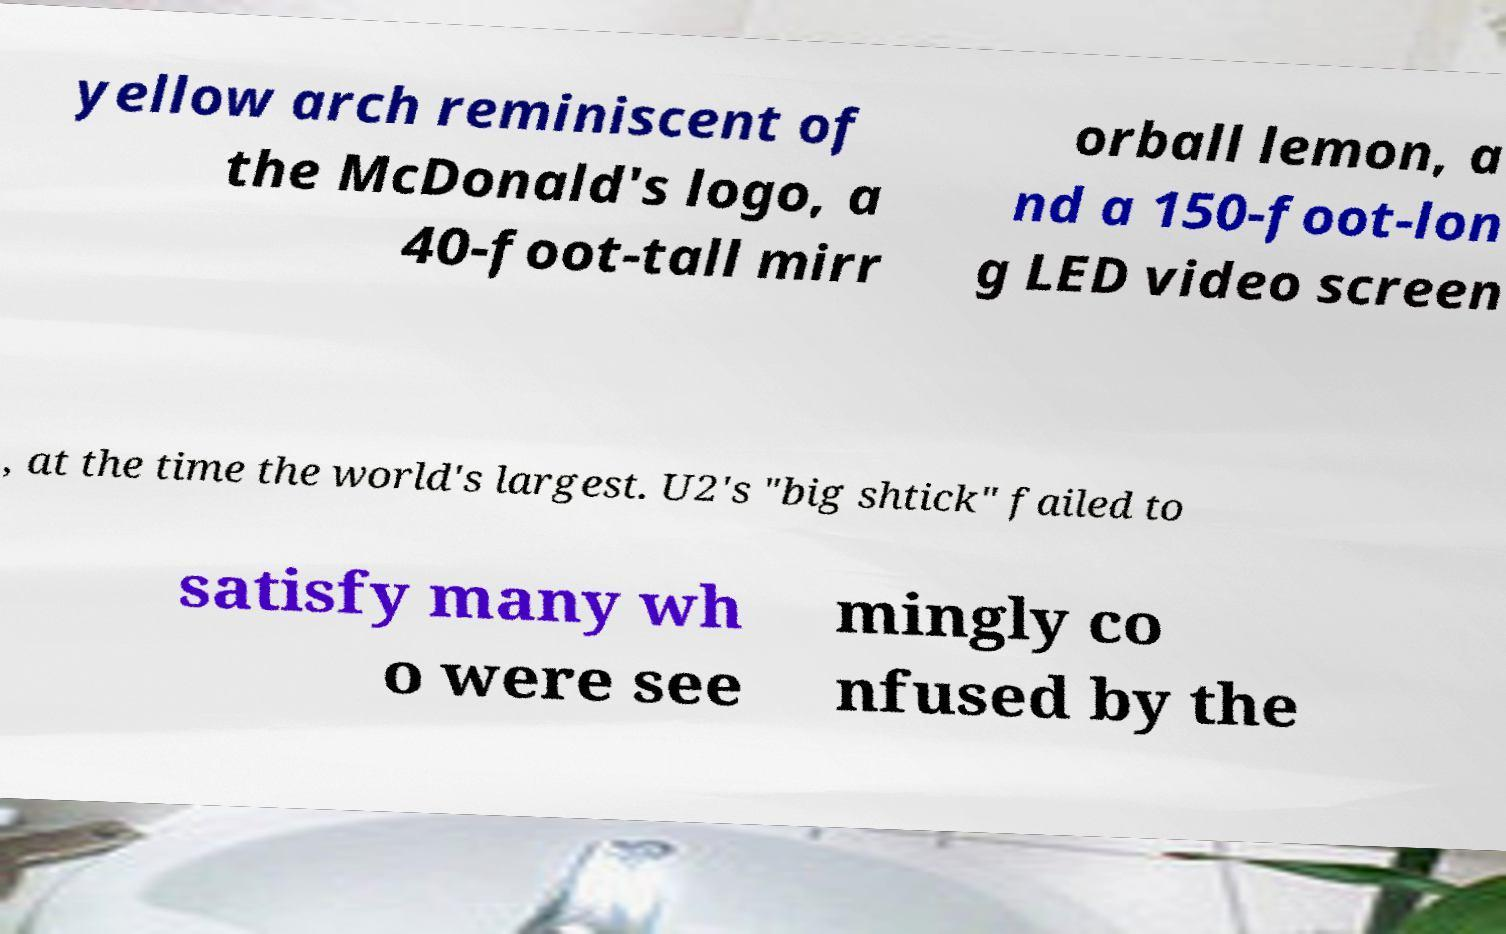Can you accurately transcribe the text from the provided image for me? yellow arch reminiscent of the McDonald's logo, a 40-foot-tall mirr orball lemon, a nd a 150-foot-lon g LED video screen , at the time the world's largest. U2's "big shtick" failed to satisfy many wh o were see mingly co nfused by the 